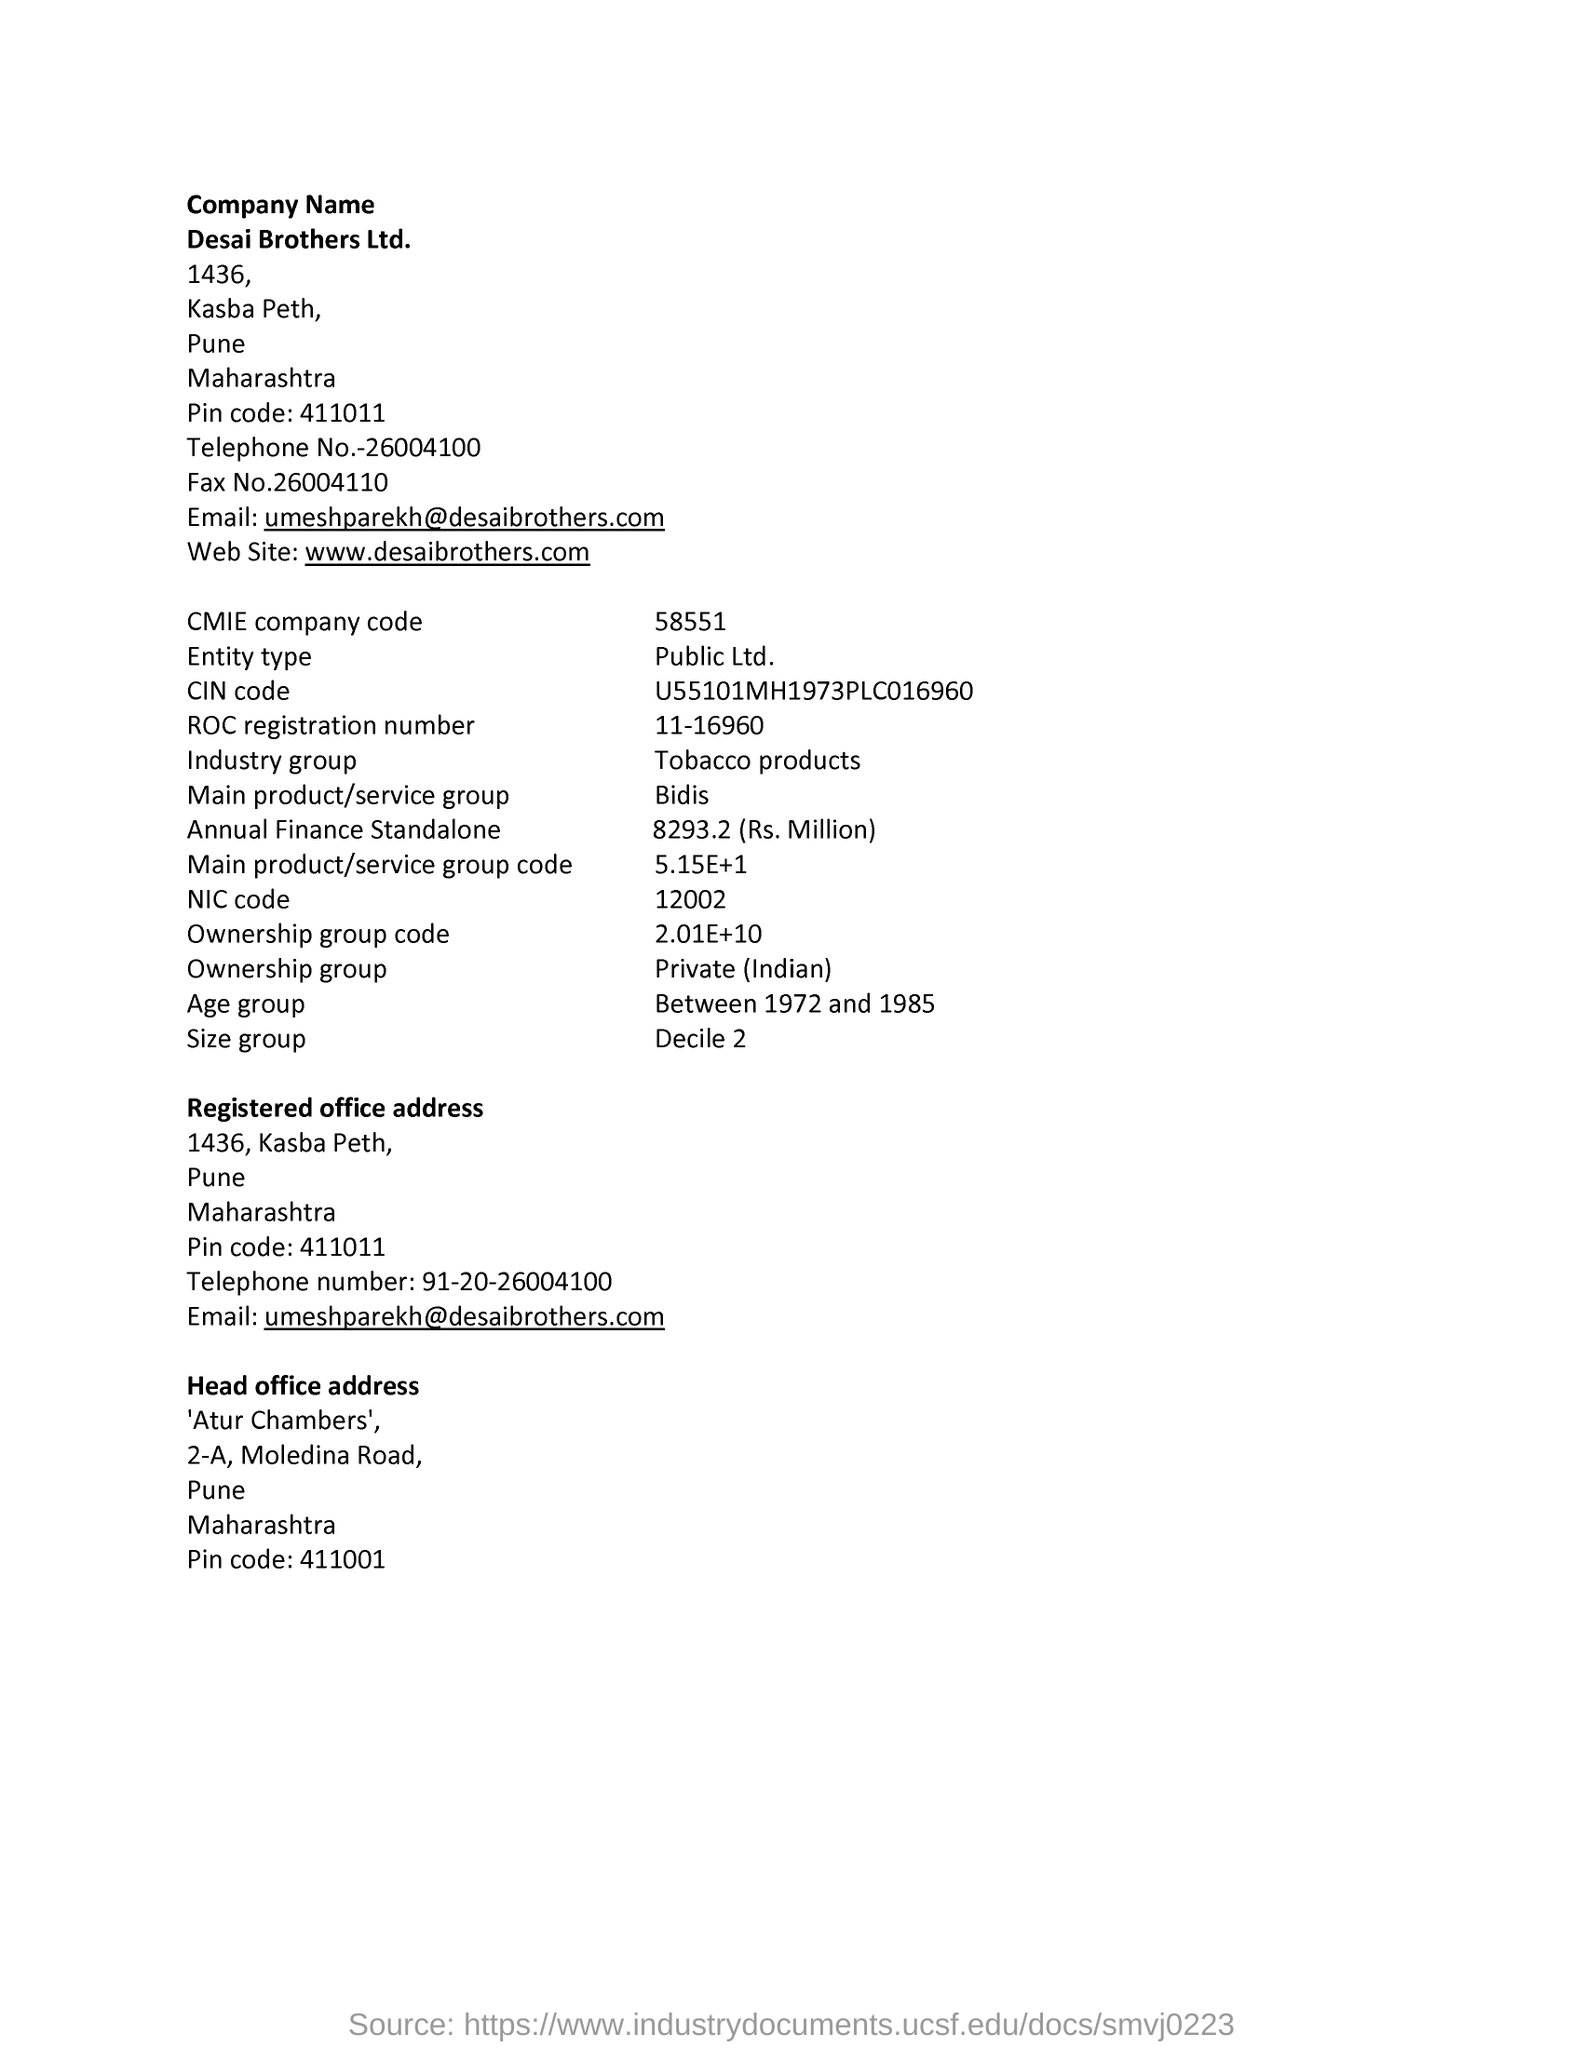Point out several critical features in this image. The main product/service group related to the company is Bidis. The company was established between 1972 and 1985, which falls within the age group of that time period. The company falls under the tobacco products industry group. The official website of Desai Brothers is [www.desaibrothers.com](http://www.desaibrothers.com). 